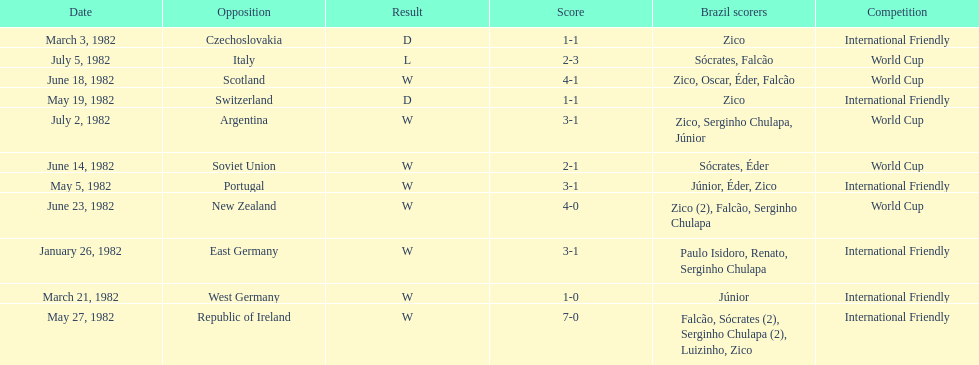What is the number of games won by brazil during the month of march 1982? 1. Would you be able to parse every entry in this table? {'header': ['Date', 'Opposition', 'Result', 'Score', 'Brazil scorers', 'Competition'], 'rows': [['March 3, 1982', 'Czechoslovakia', 'D', '1-1', 'Zico', 'International Friendly'], ['July 5, 1982', 'Italy', 'L', '2-3', 'Sócrates, Falcão', 'World Cup'], ['June 18, 1982', 'Scotland', 'W', '4-1', 'Zico, Oscar, Éder, Falcão', 'World Cup'], ['May 19, 1982', 'Switzerland', 'D', '1-1', 'Zico', 'International Friendly'], ['July 2, 1982', 'Argentina', 'W', '3-1', 'Zico, Serginho Chulapa, Júnior', 'World Cup'], ['June 14, 1982', 'Soviet Union', 'W', '2-1', 'Sócrates, Éder', 'World Cup'], ['May 5, 1982', 'Portugal', 'W', '3-1', 'Júnior, Éder, Zico', 'International Friendly'], ['June 23, 1982', 'New Zealand', 'W', '4-0', 'Zico (2), Falcão, Serginho Chulapa', 'World Cup'], ['January 26, 1982', 'East Germany', 'W', '3-1', 'Paulo Isidoro, Renato, Serginho Chulapa', 'International Friendly'], ['March 21, 1982', 'West Germany', 'W', '1-0', 'Júnior', 'International Friendly'], ['May 27, 1982', 'Republic of Ireland', 'W', '7-0', 'Falcão, Sócrates (2), Serginho Chulapa (2), Luizinho, Zico', 'International Friendly']]} 